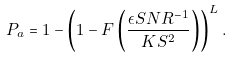Convert formula to latex. <formula><loc_0><loc_0><loc_500><loc_500>P _ { a } & = 1 - \left ( 1 - F \left ( \frac { \epsilon S N R ^ { - 1 } } { K S ^ { 2 } } \right ) \right ) ^ { L } .</formula> 